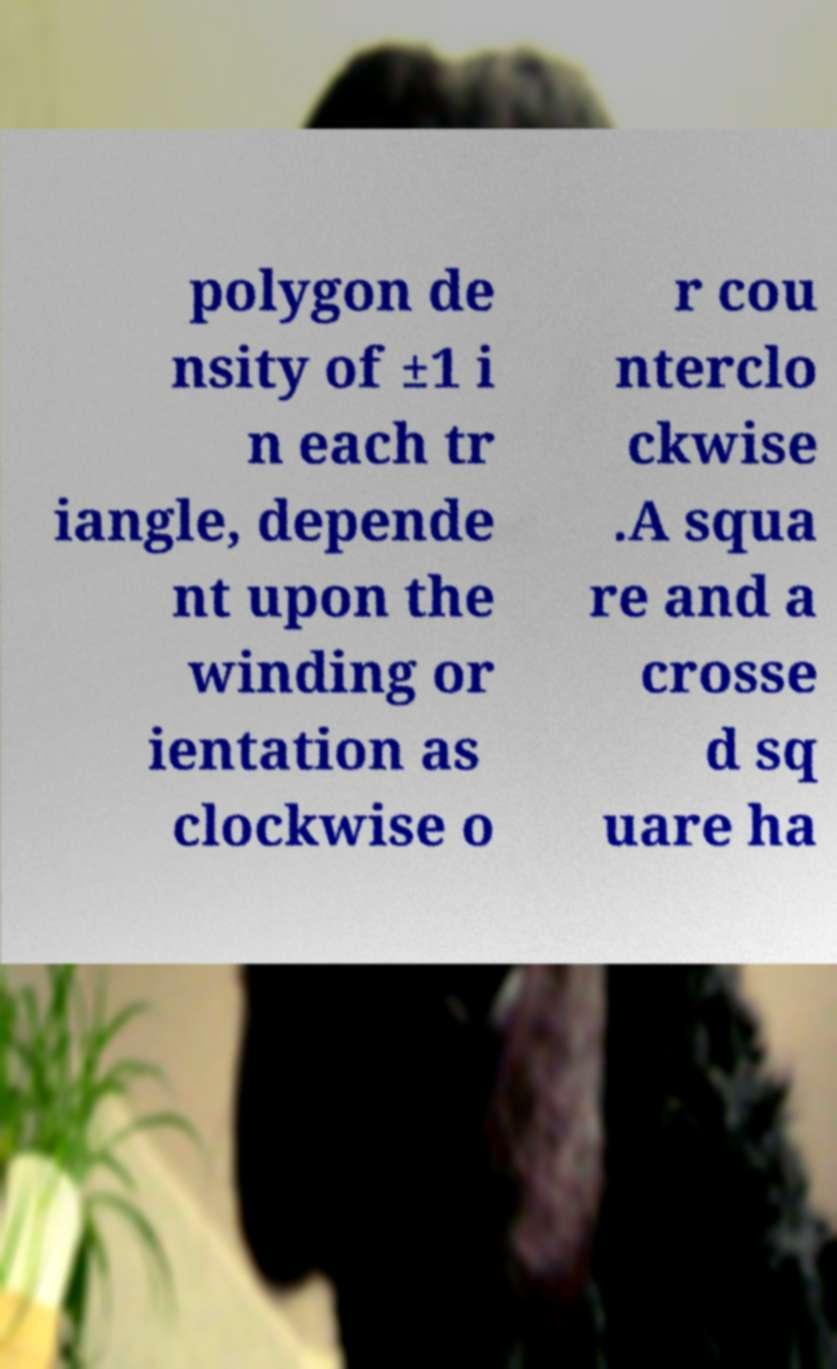Could you assist in decoding the text presented in this image and type it out clearly? polygon de nsity of ±1 i n each tr iangle, depende nt upon the winding or ientation as clockwise o r cou nterclo ckwise .A squa re and a crosse d sq uare ha 